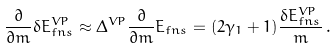Convert formula to latex. <formula><loc_0><loc_0><loc_500><loc_500>\frac { \partial } { \partial m } \delta E ^ { V P } _ { f n s } \approx \Delta ^ { V P } \frac { \partial } { \partial m } E _ { f n s } = ( 2 \gamma _ { 1 } + 1 ) \frac { \delta E ^ { V P } _ { f n s } } m \, .</formula> 